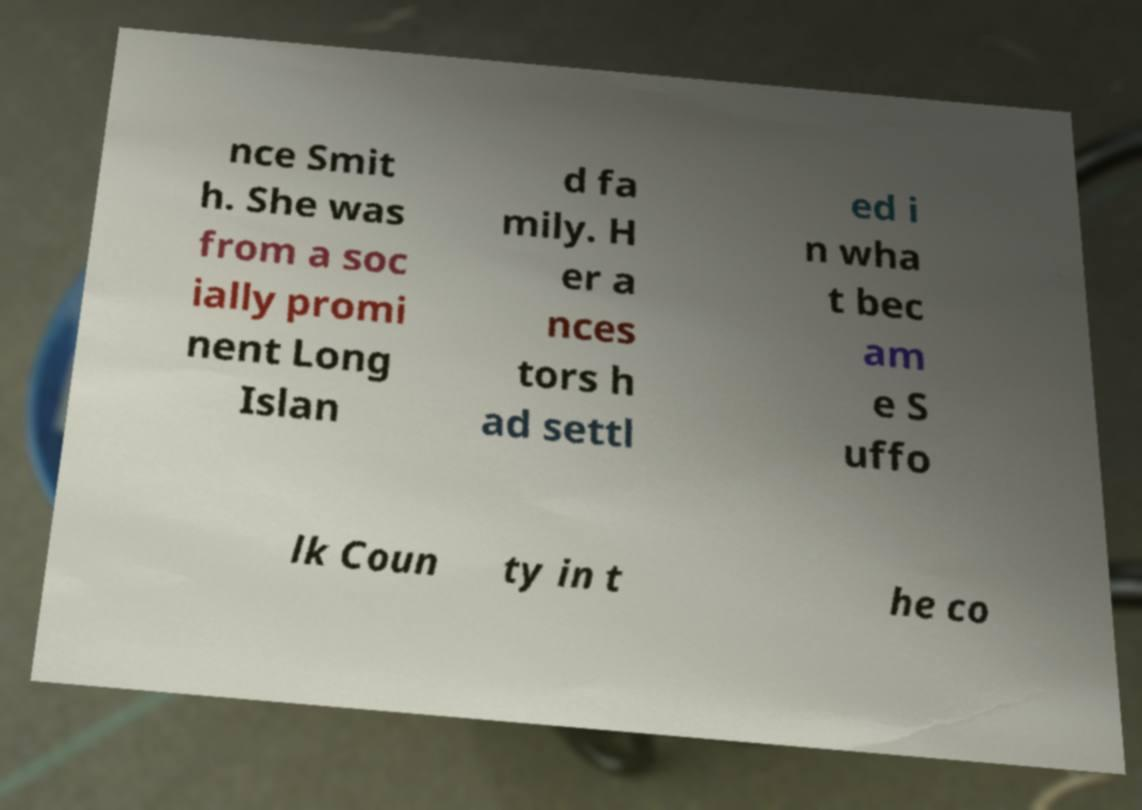Could you extract and type out the text from this image? nce Smit h. She was from a soc ially promi nent Long Islan d fa mily. H er a nces tors h ad settl ed i n wha t bec am e S uffo lk Coun ty in t he co 